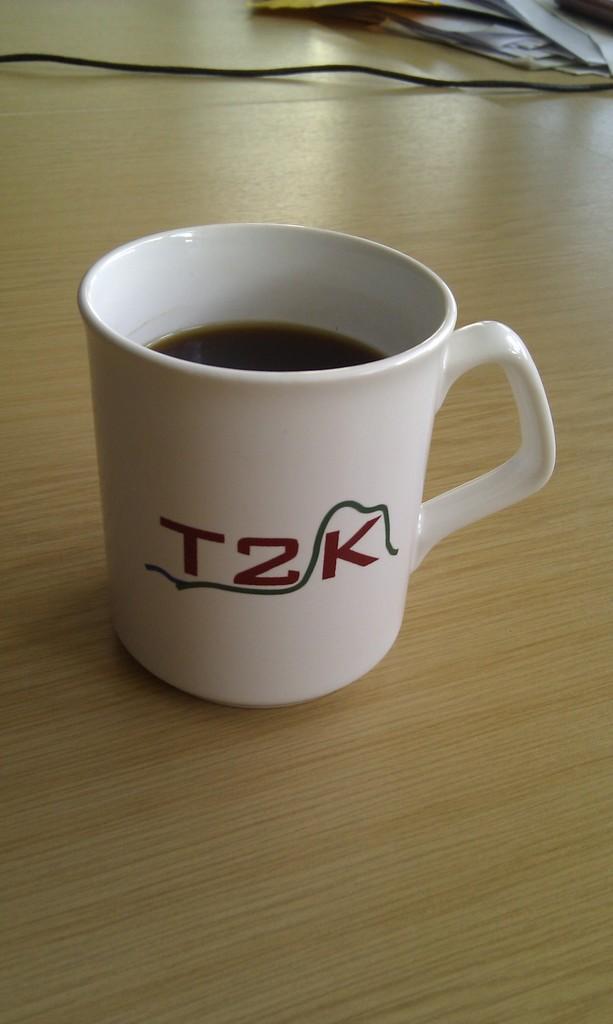How would you summarize this image in a sentence or two? It is a teacup in white color. 